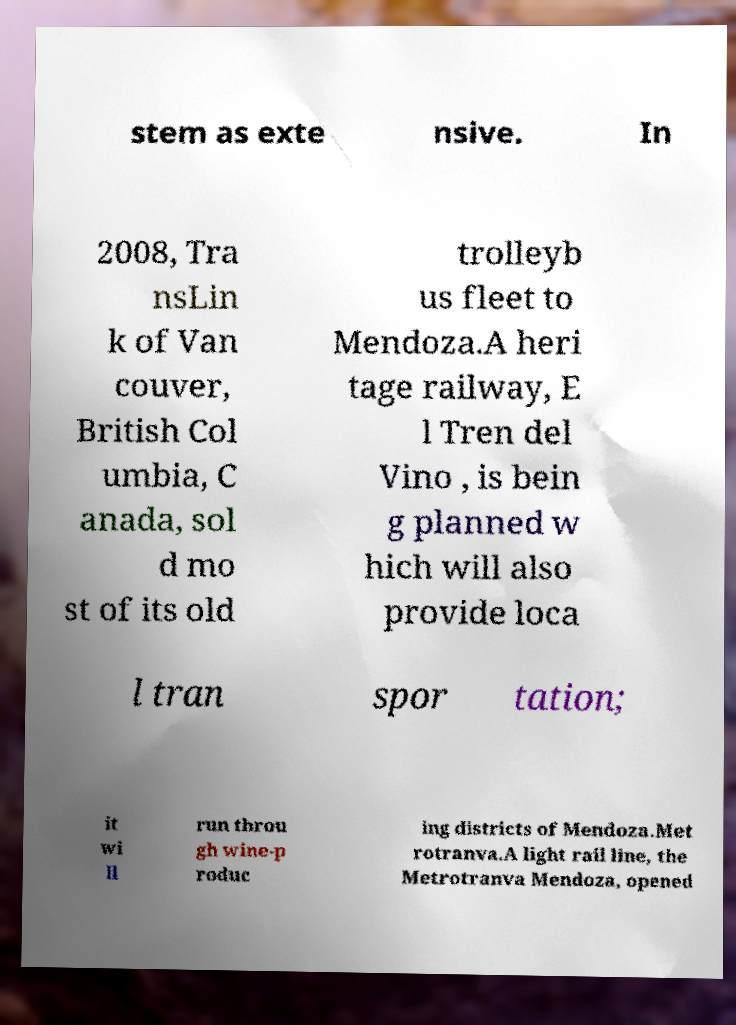There's text embedded in this image that I need extracted. Can you transcribe it verbatim? stem as exte nsive. In 2008, Tra nsLin k of Van couver, British Col umbia, C anada, sol d mo st of its old trolleyb us fleet to Mendoza.A heri tage railway, E l Tren del Vino , is bein g planned w hich will also provide loca l tran spor tation; it wi ll run throu gh wine-p roduc ing districts of Mendoza.Met rotranva.A light rail line, the Metrotranva Mendoza, opened 